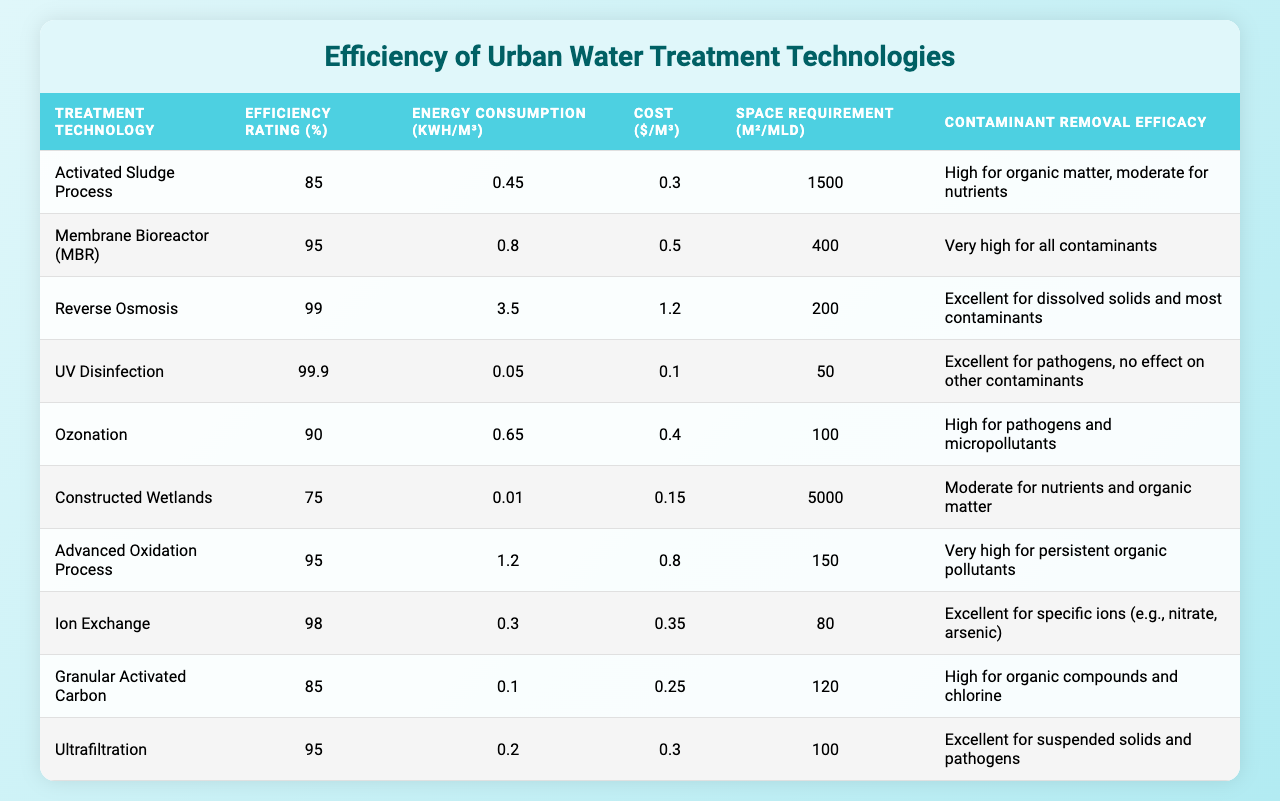What is the efficiency rating of the Reverse Osmosis technology? According to the table, the efficiency rating for Reverse Osmosis is listed in the second column next to the Treatment Technology name. It shows an efficiency rating of 99%.
Answer: 99% Which treatment technology has the highest energy consumption? Looking at the energy consumption values in the table, Reverse Osmosis shows the highest value at 3.50 kWh/m³.
Answer: Reverse Osmosis What is the cost per cubic meter of the Ion Exchange technology? The cost per cubic meter for Ion Exchange is specified in the table, and it indicates a cost of $0.35/m³.
Answer: $0.35 Which technology has the lowest efficiency rating, and how much is it? Examining the table, Constructed Wetlands has the lowest efficiency rating of 75%.
Answer: 75% How many treatment technologies have an efficiency rating above 90%? The table contains five technologies with efficiency ratings above 90%: Membrane Bioreactor, Reverse Osmosis, UV Disinfection, Ozonation, and Ion Exchange.
Answer: 5 What is the average efficiency rating of all listed treatment technologies? To find the average efficiency rating, add all the efficiency ratings together: 85 + 95 + 99 + 99.9 + 90 + 75 + 95 + 98 + 85 + 95 = 1011. Then divide by the total number of technologies (10), which results in an average of 101.1.
Answer: 101.1 Which treatment technologies can effectively remove pathogens? The table lists multiple technologies effective for pathogen removal: UV Disinfection, Ozonation, and Ultrafiltration.
Answer: UV Disinfection, Ozonation, Ultrafiltration Is the cost per cubic meter for Membrane Bioreactor higher than that of Activated Sludge Process? Comparing the costs in the table, Membrane Bioreactor ($0.50/m³) is indeed higher than Activated Sludge Process ($0.30/m³).
Answer: Yes Which of the technologies requires the most space? The table indicates that Constructed Wetlands has the highest space requirement at 5000 m²/MLD.
Answer: Constructed Wetlands If I wanted to reduce energy consumption, which technology should I avoid? To minimize energy consumption, avoid Reverse Osmosis, which has the highest value at 3.50 kWh/m³.
Answer: Reverse Osmosis 